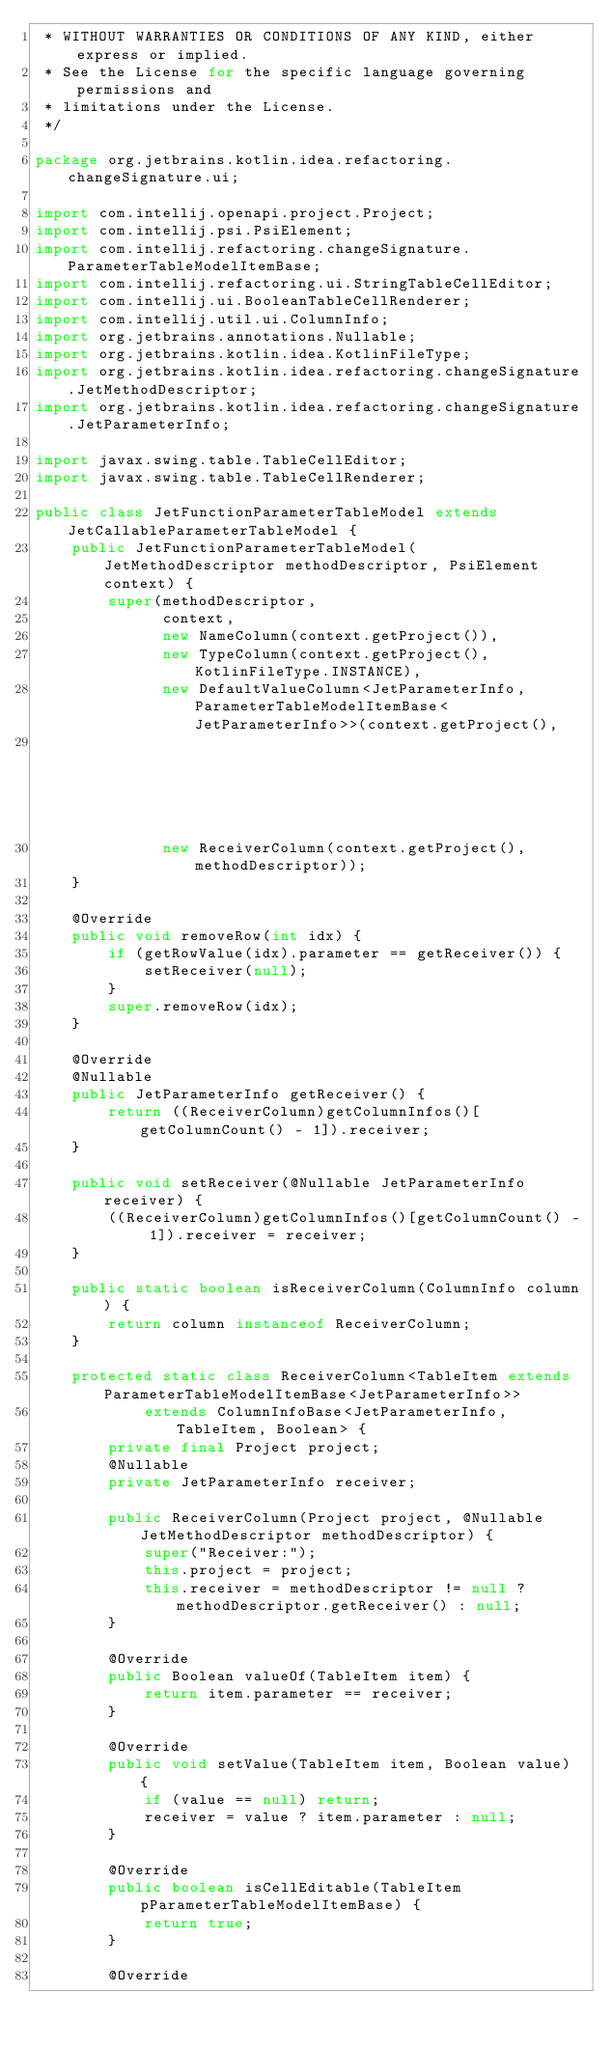Convert code to text. <code><loc_0><loc_0><loc_500><loc_500><_Java_> * WITHOUT WARRANTIES OR CONDITIONS OF ANY KIND, either express or implied.
 * See the License for the specific language governing permissions and
 * limitations under the License.
 */

package org.jetbrains.kotlin.idea.refactoring.changeSignature.ui;

import com.intellij.openapi.project.Project;
import com.intellij.psi.PsiElement;
import com.intellij.refactoring.changeSignature.ParameterTableModelItemBase;
import com.intellij.refactoring.ui.StringTableCellEditor;
import com.intellij.ui.BooleanTableCellRenderer;
import com.intellij.util.ui.ColumnInfo;
import org.jetbrains.annotations.Nullable;
import org.jetbrains.kotlin.idea.KotlinFileType;
import org.jetbrains.kotlin.idea.refactoring.changeSignature.JetMethodDescriptor;
import org.jetbrains.kotlin.idea.refactoring.changeSignature.JetParameterInfo;

import javax.swing.table.TableCellEditor;
import javax.swing.table.TableCellRenderer;

public class JetFunctionParameterTableModel extends JetCallableParameterTableModel {
    public JetFunctionParameterTableModel(JetMethodDescriptor methodDescriptor, PsiElement context) {
        super(methodDescriptor,
              context,
              new NameColumn(context.getProject()),
              new TypeColumn(context.getProject(), KotlinFileType.INSTANCE),
              new DefaultValueColumn<JetParameterInfo, ParameterTableModelItemBase<JetParameterInfo>>(context.getProject(),
                                                                                                      KotlinFileType.INSTANCE),
              new ReceiverColumn(context.getProject(), methodDescriptor));
    }

    @Override
    public void removeRow(int idx) {
        if (getRowValue(idx).parameter == getReceiver()) {
            setReceiver(null);
        }
        super.removeRow(idx);
    }

    @Override
    @Nullable
    public JetParameterInfo getReceiver() {
        return ((ReceiverColumn)getColumnInfos()[getColumnCount() - 1]).receiver;
    }

    public void setReceiver(@Nullable JetParameterInfo receiver) {
        ((ReceiverColumn)getColumnInfos()[getColumnCount() - 1]).receiver = receiver;
    }

    public static boolean isReceiverColumn(ColumnInfo column) {
        return column instanceof ReceiverColumn;
    }

    protected static class ReceiverColumn<TableItem extends ParameterTableModelItemBase<JetParameterInfo>>
            extends ColumnInfoBase<JetParameterInfo, TableItem, Boolean> {
        private final Project project;
        @Nullable
        private JetParameterInfo receiver;

        public ReceiverColumn(Project project, @Nullable JetMethodDescriptor methodDescriptor) {
            super("Receiver:");
            this.project = project;
            this.receiver = methodDescriptor != null ? methodDescriptor.getReceiver() : null;
        }

        @Override
        public Boolean valueOf(TableItem item) {
            return item.parameter == receiver;
        }

        @Override
        public void setValue(TableItem item, Boolean value) {
            if (value == null) return;
            receiver = value ? item.parameter : null;
        }

        @Override
        public boolean isCellEditable(TableItem pParameterTableModelItemBase) {
            return true;
        }

        @Override</code> 